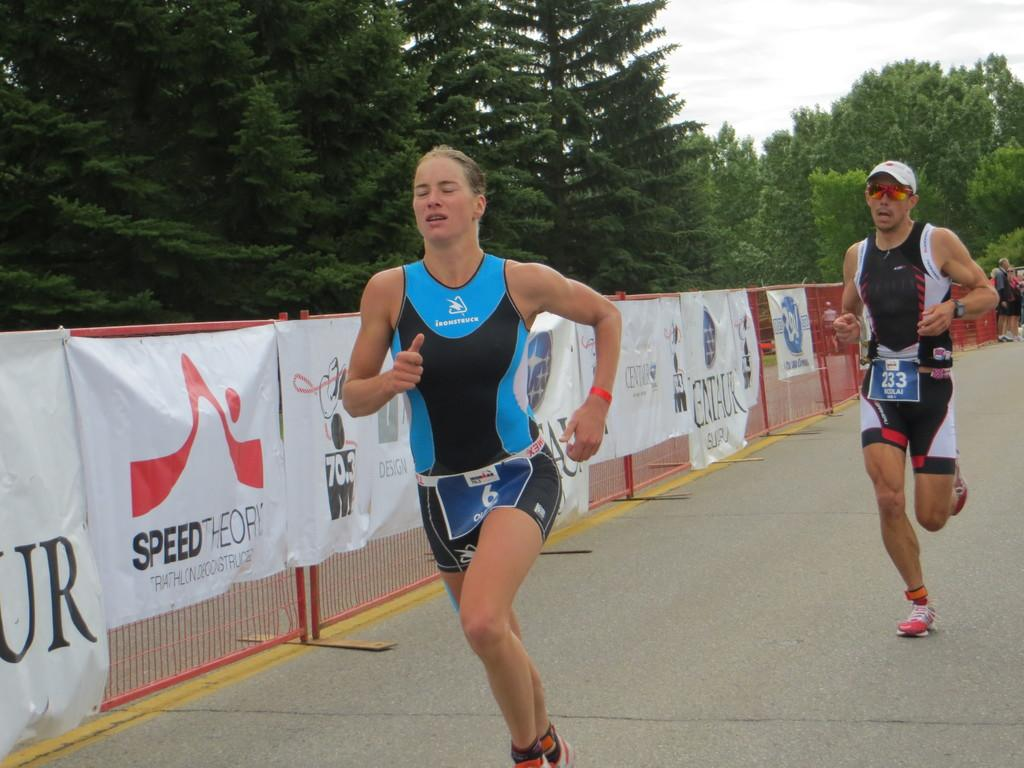<image>
Create a compact narrative representing the image presented. To the left of the competitor there is a sign for Speed Theory. 